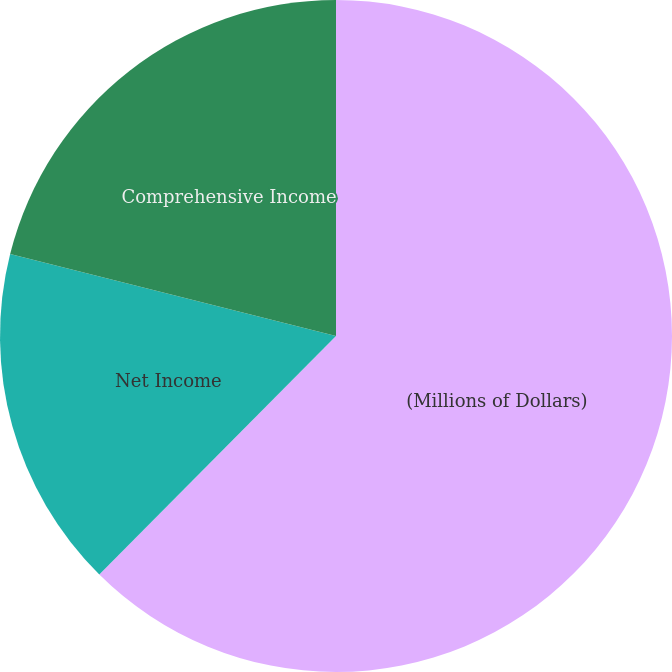Convert chart to OTSL. <chart><loc_0><loc_0><loc_500><loc_500><pie_chart><fcel>(Millions of Dollars)<fcel>Net Income<fcel>Comprehensive Income<nl><fcel>62.44%<fcel>16.48%<fcel>21.08%<nl></chart> 